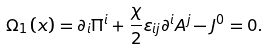Convert formula to latex. <formula><loc_0><loc_0><loc_500><loc_500>\Omega _ { 1 } \left ( x \right ) = \partial _ { i } \Pi ^ { i } + \frac { \chi } { 2 } \varepsilon _ { i j } \partial ^ { i } A ^ { j } - J ^ { 0 } = 0 .</formula> 